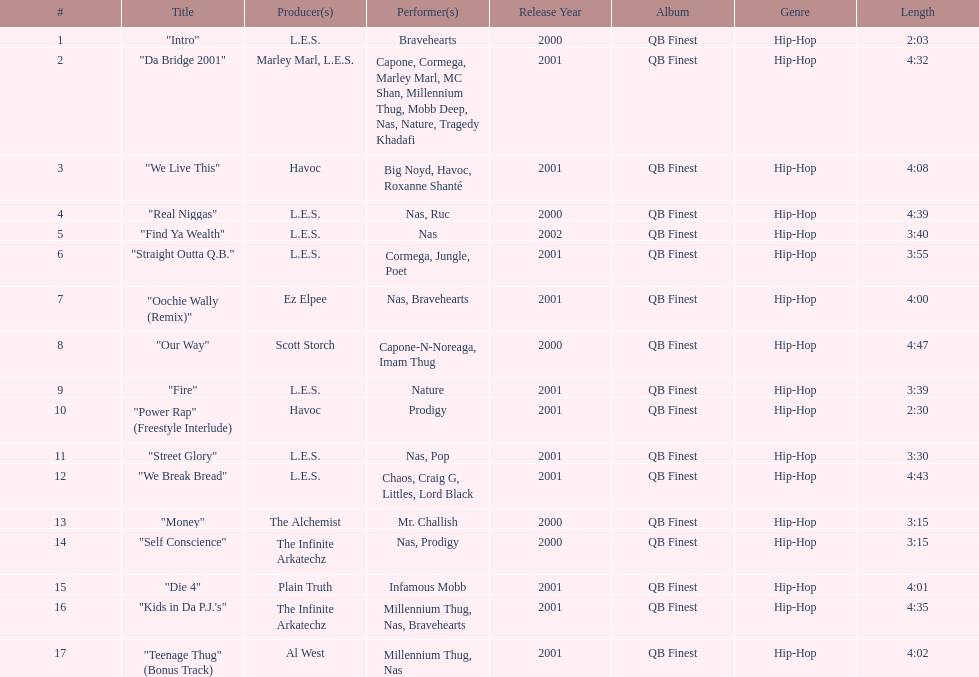How long os the longest track on the album? 4:47. 